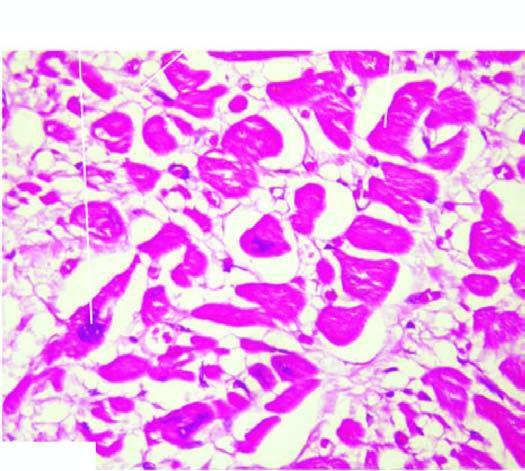how are individual myocardial fibres?
Answer the question using a single word or phrase. Thick with prominent vesicular nuclei 